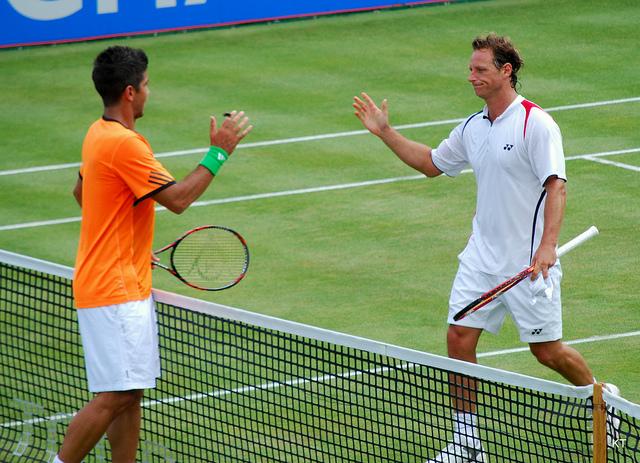What is the expression of the man in white shirt?
Answer briefly. Disappointed. What color is the man's shirt on the right?
Answer briefly. White. What is on his arm?
Give a very brief answer. Wristband. 